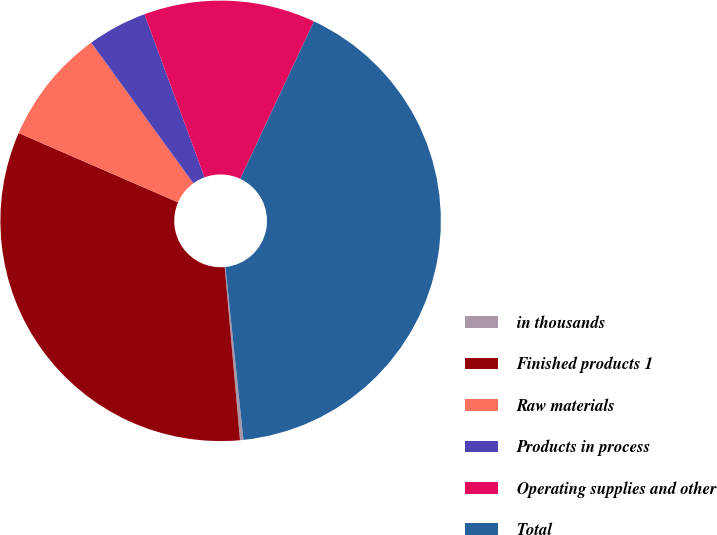<chart> <loc_0><loc_0><loc_500><loc_500><pie_chart><fcel>in thousands<fcel>Finished products 1<fcel>Raw materials<fcel>Products in process<fcel>Operating supplies and other<fcel>Total<nl><fcel>0.25%<fcel>32.93%<fcel>8.48%<fcel>4.37%<fcel>12.59%<fcel>41.38%<nl></chart> 